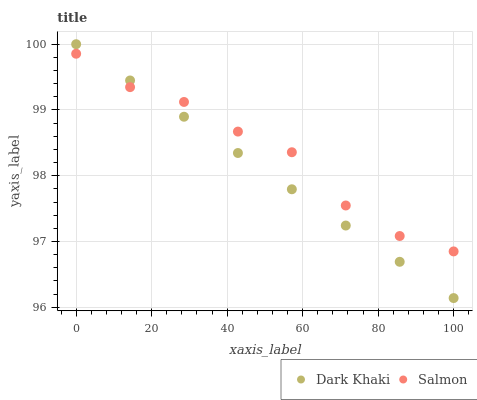Does Dark Khaki have the minimum area under the curve?
Answer yes or no. Yes. Does Salmon have the maximum area under the curve?
Answer yes or no. Yes. Does Salmon have the minimum area under the curve?
Answer yes or no. No. Is Dark Khaki the smoothest?
Answer yes or no. Yes. Is Salmon the roughest?
Answer yes or no. Yes. Is Salmon the smoothest?
Answer yes or no. No. Does Dark Khaki have the lowest value?
Answer yes or no. Yes. Does Salmon have the lowest value?
Answer yes or no. No. Does Dark Khaki have the highest value?
Answer yes or no. Yes. Does Salmon have the highest value?
Answer yes or no. No. Does Dark Khaki intersect Salmon?
Answer yes or no. Yes. Is Dark Khaki less than Salmon?
Answer yes or no. No. Is Dark Khaki greater than Salmon?
Answer yes or no. No. 